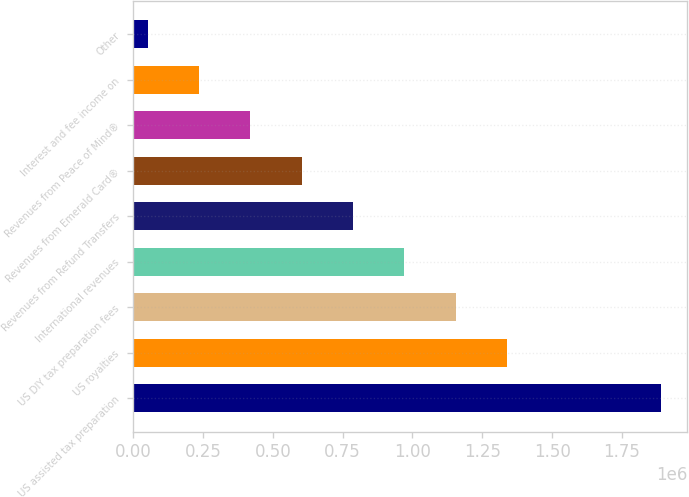<chart> <loc_0><loc_0><loc_500><loc_500><bar_chart><fcel>US assisted tax preparation<fcel>US royalties<fcel>US DIY tax preparation fees<fcel>International revenues<fcel>Revenues from Refund Transfers<fcel>Revenues from Emerald Card®<fcel>Revenues from Peace of Mind®<fcel>Interest and fee income on<fcel>Other<nl><fcel>1.89018e+06<fcel>1.33858e+06<fcel>1.15472e+06<fcel>970856<fcel>786993<fcel>603129<fcel>419265<fcel>235402<fcel>51538<nl></chart> 